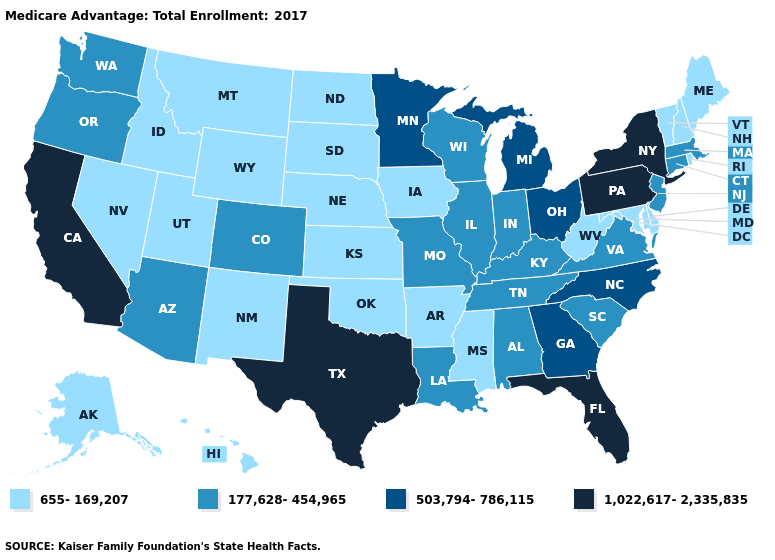Does Oklahoma have the same value as Maine?
Concise answer only. Yes. Does Delaware have the lowest value in the USA?
Short answer required. Yes. What is the highest value in states that border South Dakota?
Concise answer only. 503,794-786,115. Name the states that have a value in the range 655-169,207?
Be succinct. Alaska, Arkansas, Delaware, Hawaii, Iowa, Idaho, Kansas, Maryland, Maine, Mississippi, Montana, North Dakota, Nebraska, New Hampshire, New Mexico, Nevada, Oklahoma, Rhode Island, South Dakota, Utah, Vermont, West Virginia, Wyoming. What is the value of Georgia?
Give a very brief answer. 503,794-786,115. Which states hav the highest value in the South?
Quick response, please. Florida, Texas. What is the highest value in states that border Mississippi?
Keep it brief. 177,628-454,965. What is the highest value in the USA?
Quick response, please. 1,022,617-2,335,835. Name the states that have a value in the range 503,794-786,115?
Answer briefly. Georgia, Michigan, Minnesota, North Carolina, Ohio. Does the map have missing data?
Write a very short answer. No. What is the value of Arizona?
Concise answer only. 177,628-454,965. Among the states that border New Jersey , which have the lowest value?
Give a very brief answer. Delaware. Which states have the lowest value in the Northeast?
Quick response, please. Maine, New Hampshire, Rhode Island, Vermont. What is the value of Oregon?
Write a very short answer. 177,628-454,965. What is the value of Kentucky?
Write a very short answer. 177,628-454,965. 